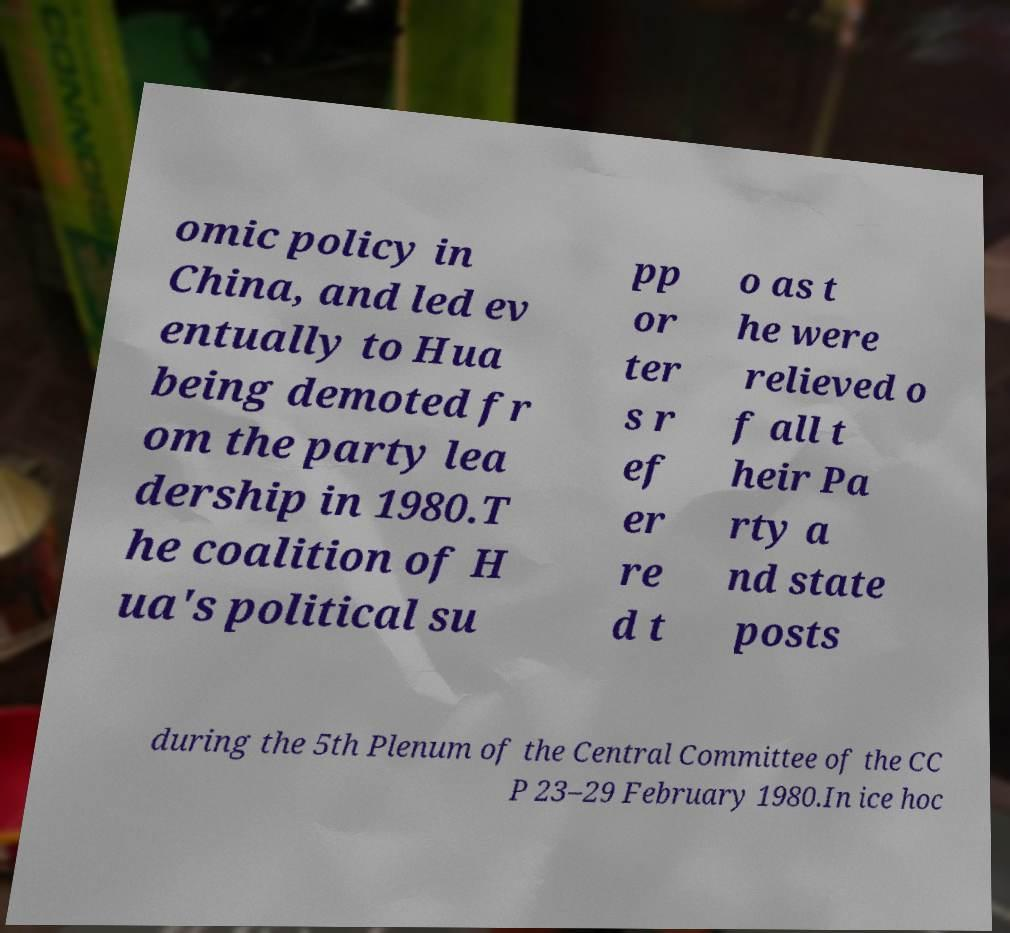What messages or text are displayed in this image? I need them in a readable, typed format. omic policy in China, and led ev entually to Hua being demoted fr om the party lea dership in 1980.T he coalition of H ua's political su pp or ter s r ef er re d t o as t he were relieved o f all t heir Pa rty a nd state posts during the 5th Plenum of the Central Committee of the CC P 23–29 February 1980.In ice hoc 